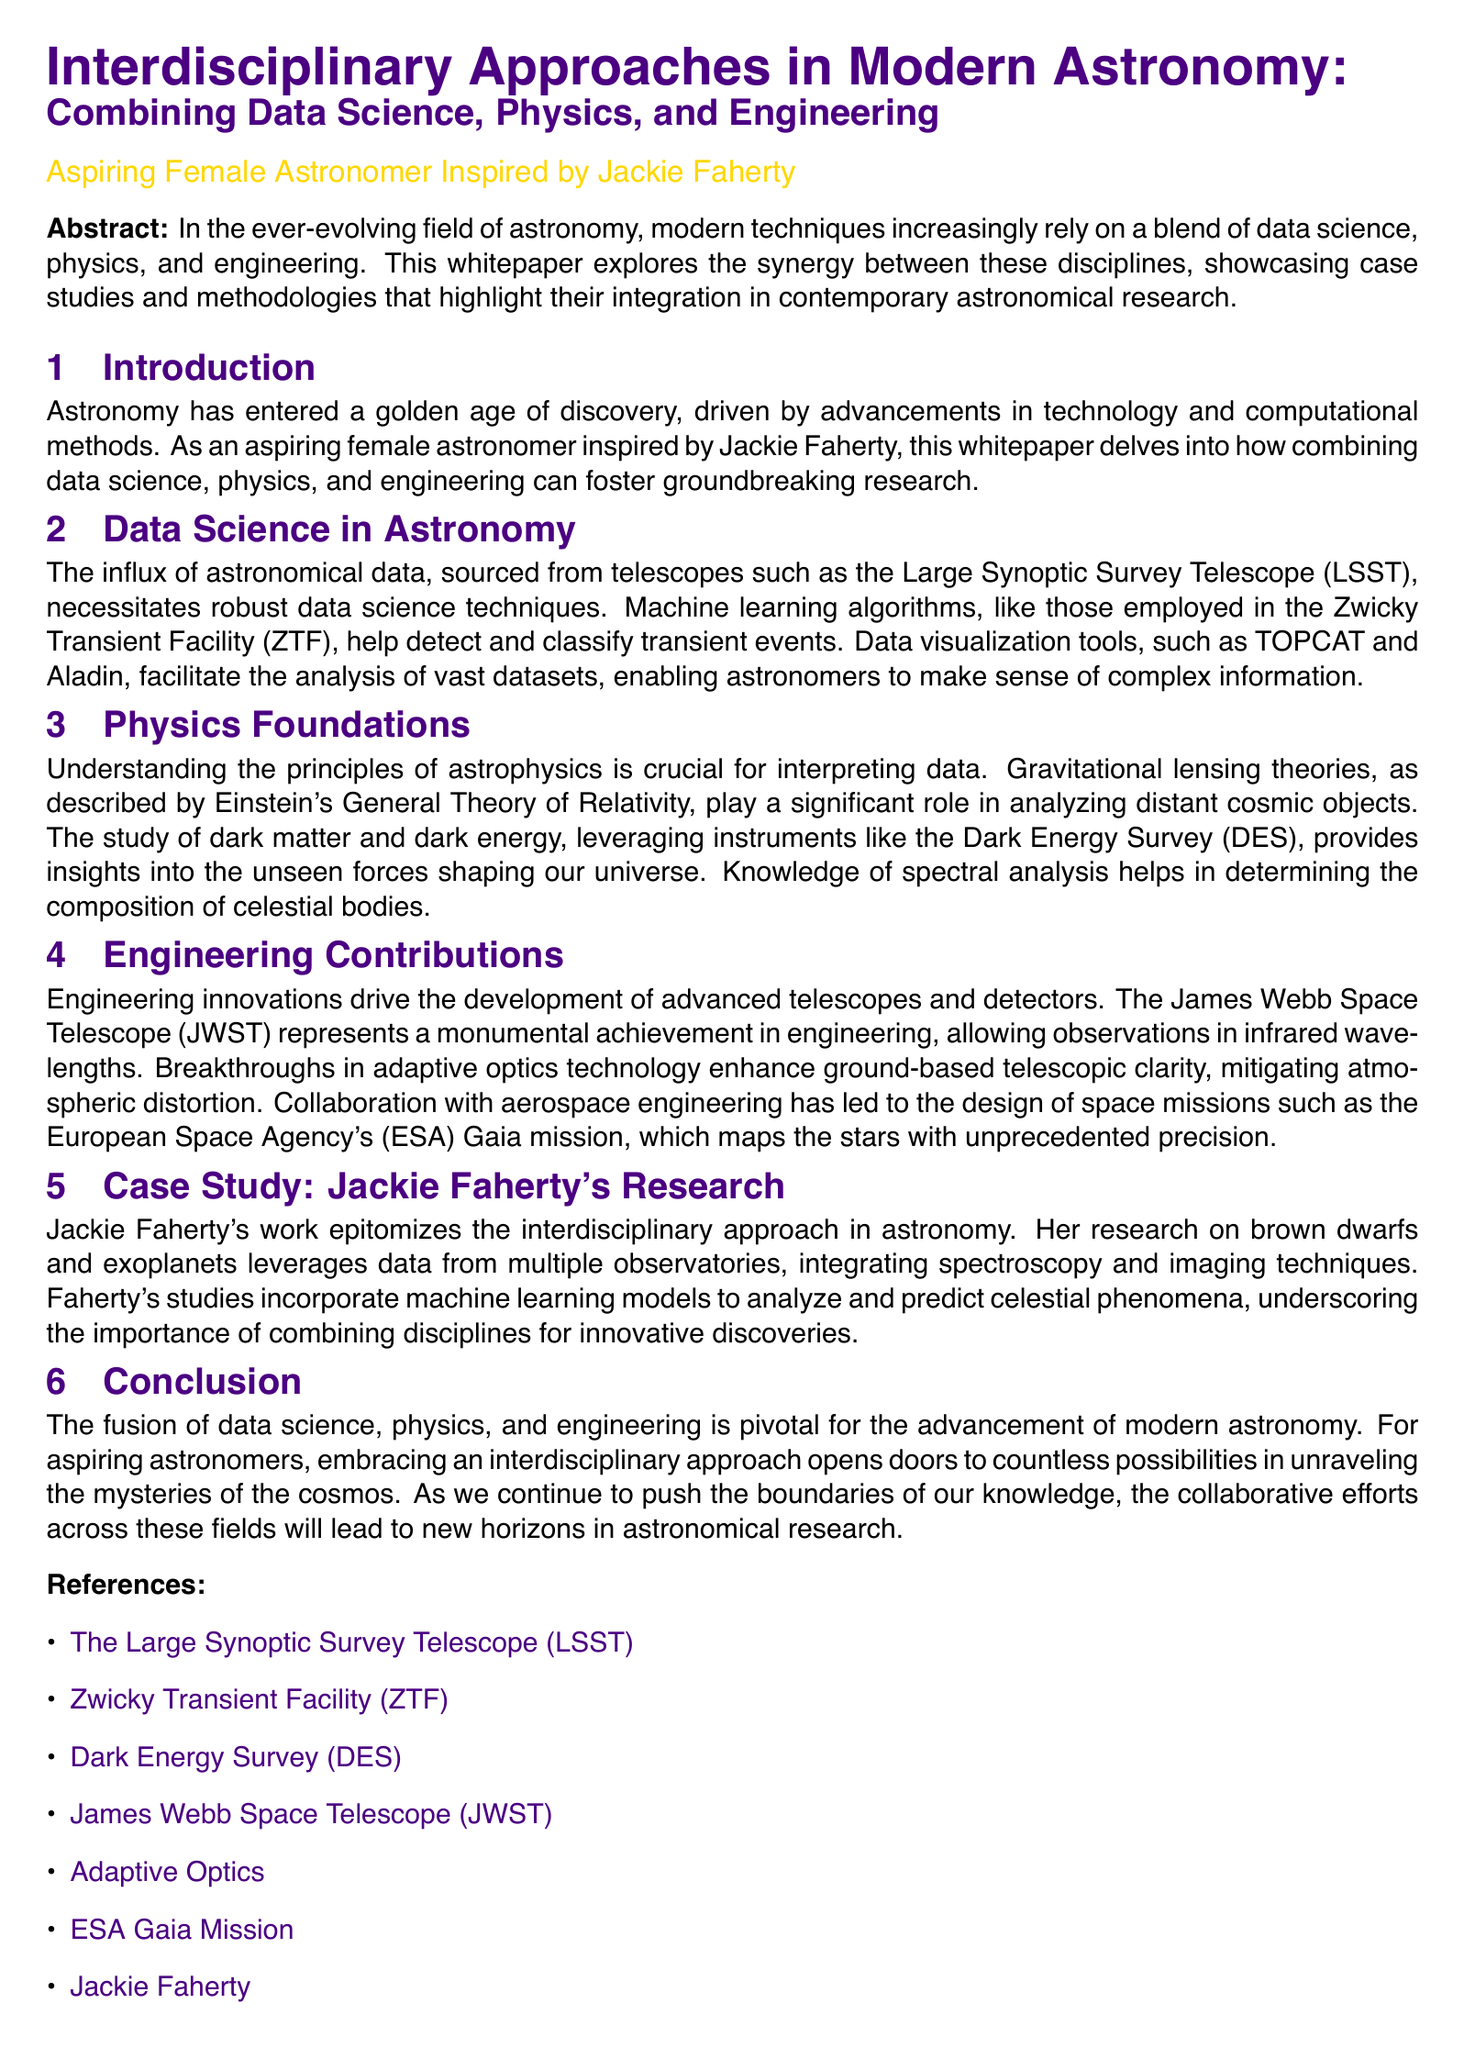What is the main focus of the whitepaper? The main focus of the whitepaper is on combining data science, physics, and engineering in modern astronomy.
Answer: Combining data science, physics, and engineering Which telescope is associated with the Large Synoptic Survey Telescope? The document mentions the LSST in the context of astronomical data influx necessitating robust data science techniques.
Answer: LSST What innovative technology enhances ground-based telescopic clarity? The whitepaper refers to breakthroughs in adaptive optics technology that improve observatory clarity.
Answer: Adaptive optics Who is the featured researcher in the case study section? The research case study highlights the work of an individual in interdisciplinary astronomy research.
Answer: Jackie Faherty What is one of the instruments used to study dark matter according to the document? The passage mentions the Dark Energy Survey as a crucial instrument for understanding dark matter.
Answer: Dark Energy Survey According to the document, what approach should aspiring astronomers embrace? The whitepaper suggests that aspiring astronomers should adopt a collaborative approach to broaden their research capabilities.
Answer: Interdisciplinary approach What are the names of the objects Jackie Faherty studies? The case study focuses on specific types of celestial objects in her research work.
Answer: Brown dwarfs and exoplanets What role does machine learning play in Faherty's research? Machine learning is applied in her research to analyze and predict celestial phenomena.
Answer: Analyze and predict celestial phenomena 